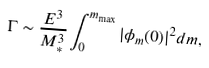Convert formula to latex. <formula><loc_0><loc_0><loc_500><loc_500>\Gamma \sim { \frac { E ^ { 3 } } { M _ { * } ^ { 3 } } } \int _ { 0 } ^ { m _ { \max } } | \phi _ { m } ( 0 ) | ^ { 2 } d m ,</formula> 